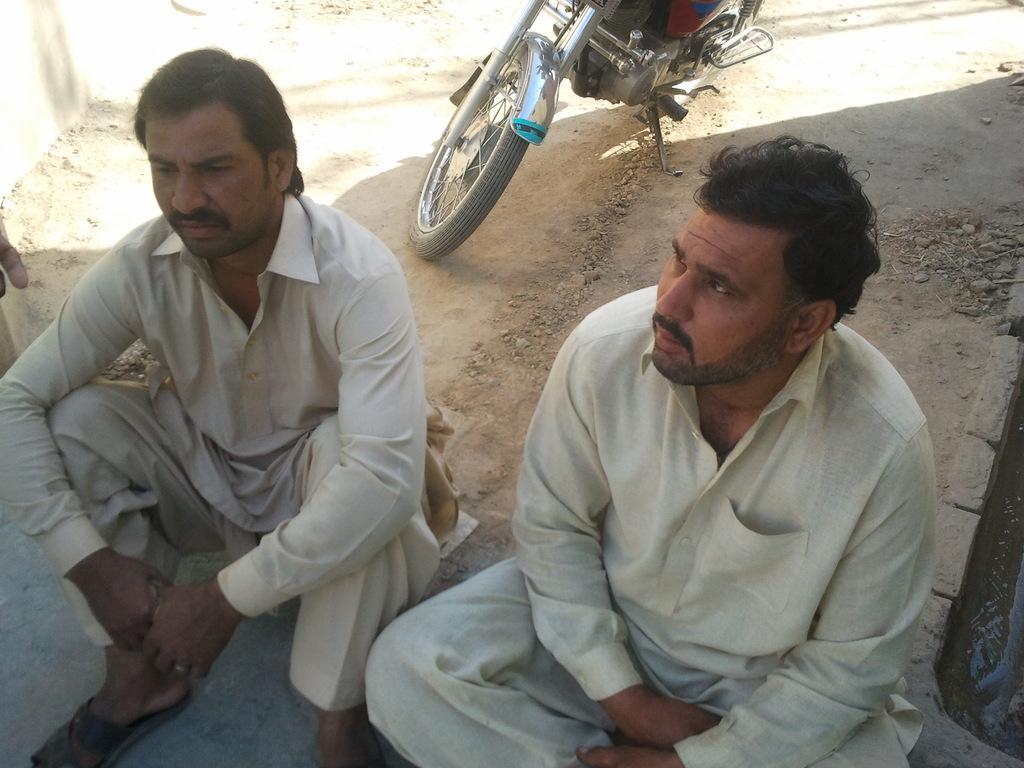Could you give a brief overview of what you see in this image? In this image, we can see persons wearing clothes and sitting on the ground. There is a motorcycle at the top of the image. 